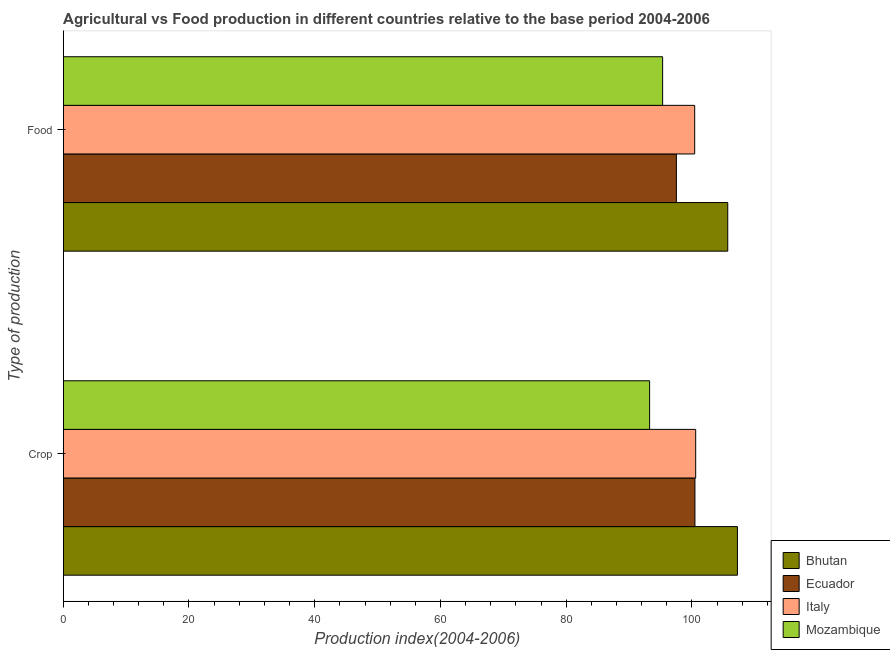How many different coloured bars are there?
Provide a short and direct response. 4. How many groups of bars are there?
Provide a short and direct response. 2. Are the number of bars per tick equal to the number of legend labels?
Provide a short and direct response. Yes. How many bars are there on the 1st tick from the top?
Give a very brief answer. 4. What is the label of the 1st group of bars from the top?
Keep it short and to the point. Food. What is the food production index in Bhutan?
Your answer should be very brief. 105.69. Across all countries, what is the maximum food production index?
Keep it short and to the point. 105.69. Across all countries, what is the minimum food production index?
Your answer should be compact. 95.33. In which country was the food production index maximum?
Ensure brevity in your answer.  Bhutan. In which country was the food production index minimum?
Your response must be concise. Mozambique. What is the total food production index in the graph?
Offer a terse response. 398.97. What is the difference between the food production index in Bhutan and that in Mozambique?
Keep it short and to the point. 10.36. What is the difference between the crop production index in Italy and the food production index in Mozambique?
Your answer should be very brief. 5.26. What is the average crop production index per country?
Provide a short and direct response. 100.39. What is the difference between the food production index and crop production index in Ecuador?
Your response must be concise. -2.95. In how many countries, is the crop production index greater than 68 ?
Keep it short and to the point. 4. What is the ratio of the food production index in Mozambique to that in Italy?
Your response must be concise. 0.95. In how many countries, is the food production index greater than the average food production index taken over all countries?
Your answer should be very brief. 2. What does the 3rd bar from the top in Crop represents?
Your answer should be very brief. Ecuador. What does the 4th bar from the bottom in Crop represents?
Keep it short and to the point. Mozambique. Are all the bars in the graph horizontal?
Your answer should be very brief. Yes. What is the difference between two consecutive major ticks on the X-axis?
Provide a succinct answer. 20. Are the values on the major ticks of X-axis written in scientific E-notation?
Offer a very short reply. No. Does the graph contain any zero values?
Keep it short and to the point. No. How are the legend labels stacked?
Provide a short and direct response. Vertical. What is the title of the graph?
Keep it short and to the point. Agricultural vs Food production in different countries relative to the base period 2004-2006. Does "Mali" appear as one of the legend labels in the graph?
Your response must be concise. No. What is the label or title of the X-axis?
Provide a succinct answer. Production index(2004-2006). What is the label or title of the Y-axis?
Your response must be concise. Type of production. What is the Production index(2004-2006) of Bhutan in Crop?
Provide a short and direct response. 107.23. What is the Production index(2004-2006) of Ecuador in Crop?
Keep it short and to the point. 100.47. What is the Production index(2004-2006) in Italy in Crop?
Make the answer very short. 100.59. What is the Production index(2004-2006) of Mozambique in Crop?
Provide a succinct answer. 93.26. What is the Production index(2004-2006) of Bhutan in Food?
Ensure brevity in your answer.  105.69. What is the Production index(2004-2006) in Ecuador in Food?
Offer a terse response. 97.52. What is the Production index(2004-2006) of Italy in Food?
Provide a succinct answer. 100.43. What is the Production index(2004-2006) in Mozambique in Food?
Offer a terse response. 95.33. Across all Type of production, what is the maximum Production index(2004-2006) in Bhutan?
Offer a terse response. 107.23. Across all Type of production, what is the maximum Production index(2004-2006) of Ecuador?
Make the answer very short. 100.47. Across all Type of production, what is the maximum Production index(2004-2006) in Italy?
Make the answer very short. 100.59. Across all Type of production, what is the maximum Production index(2004-2006) of Mozambique?
Ensure brevity in your answer.  95.33. Across all Type of production, what is the minimum Production index(2004-2006) in Bhutan?
Give a very brief answer. 105.69. Across all Type of production, what is the minimum Production index(2004-2006) of Ecuador?
Your response must be concise. 97.52. Across all Type of production, what is the minimum Production index(2004-2006) of Italy?
Offer a very short reply. 100.43. Across all Type of production, what is the minimum Production index(2004-2006) in Mozambique?
Keep it short and to the point. 93.26. What is the total Production index(2004-2006) in Bhutan in the graph?
Offer a very short reply. 212.92. What is the total Production index(2004-2006) in Ecuador in the graph?
Provide a succinct answer. 197.99. What is the total Production index(2004-2006) of Italy in the graph?
Ensure brevity in your answer.  201.02. What is the total Production index(2004-2006) of Mozambique in the graph?
Provide a short and direct response. 188.59. What is the difference between the Production index(2004-2006) of Bhutan in Crop and that in Food?
Your response must be concise. 1.54. What is the difference between the Production index(2004-2006) in Ecuador in Crop and that in Food?
Offer a terse response. 2.95. What is the difference between the Production index(2004-2006) in Italy in Crop and that in Food?
Give a very brief answer. 0.16. What is the difference between the Production index(2004-2006) of Mozambique in Crop and that in Food?
Give a very brief answer. -2.07. What is the difference between the Production index(2004-2006) in Bhutan in Crop and the Production index(2004-2006) in Ecuador in Food?
Offer a very short reply. 9.71. What is the difference between the Production index(2004-2006) in Bhutan in Crop and the Production index(2004-2006) in Mozambique in Food?
Offer a terse response. 11.9. What is the difference between the Production index(2004-2006) of Ecuador in Crop and the Production index(2004-2006) of Italy in Food?
Give a very brief answer. 0.04. What is the difference between the Production index(2004-2006) of Ecuador in Crop and the Production index(2004-2006) of Mozambique in Food?
Make the answer very short. 5.14. What is the difference between the Production index(2004-2006) of Italy in Crop and the Production index(2004-2006) of Mozambique in Food?
Provide a succinct answer. 5.26. What is the average Production index(2004-2006) in Bhutan per Type of production?
Offer a terse response. 106.46. What is the average Production index(2004-2006) of Ecuador per Type of production?
Offer a very short reply. 99. What is the average Production index(2004-2006) in Italy per Type of production?
Make the answer very short. 100.51. What is the average Production index(2004-2006) in Mozambique per Type of production?
Your answer should be compact. 94.3. What is the difference between the Production index(2004-2006) in Bhutan and Production index(2004-2006) in Ecuador in Crop?
Make the answer very short. 6.76. What is the difference between the Production index(2004-2006) in Bhutan and Production index(2004-2006) in Italy in Crop?
Offer a terse response. 6.64. What is the difference between the Production index(2004-2006) in Bhutan and Production index(2004-2006) in Mozambique in Crop?
Keep it short and to the point. 13.97. What is the difference between the Production index(2004-2006) of Ecuador and Production index(2004-2006) of Italy in Crop?
Make the answer very short. -0.12. What is the difference between the Production index(2004-2006) in Ecuador and Production index(2004-2006) in Mozambique in Crop?
Ensure brevity in your answer.  7.21. What is the difference between the Production index(2004-2006) in Italy and Production index(2004-2006) in Mozambique in Crop?
Your response must be concise. 7.33. What is the difference between the Production index(2004-2006) in Bhutan and Production index(2004-2006) in Ecuador in Food?
Your answer should be compact. 8.17. What is the difference between the Production index(2004-2006) of Bhutan and Production index(2004-2006) of Italy in Food?
Your answer should be very brief. 5.26. What is the difference between the Production index(2004-2006) of Bhutan and Production index(2004-2006) of Mozambique in Food?
Your answer should be compact. 10.36. What is the difference between the Production index(2004-2006) of Ecuador and Production index(2004-2006) of Italy in Food?
Offer a very short reply. -2.91. What is the difference between the Production index(2004-2006) in Ecuador and Production index(2004-2006) in Mozambique in Food?
Offer a terse response. 2.19. What is the ratio of the Production index(2004-2006) of Bhutan in Crop to that in Food?
Your answer should be compact. 1.01. What is the ratio of the Production index(2004-2006) of Ecuador in Crop to that in Food?
Your response must be concise. 1.03. What is the ratio of the Production index(2004-2006) in Italy in Crop to that in Food?
Offer a very short reply. 1. What is the ratio of the Production index(2004-2006) of Mozambique in Crop to that in Food?
Your answer should be very brief. 0.98. What is the difference between the highest and the second highest Production index(2004-2006) in Bhutan?
Ensure brevity in your answer.  1.54. What is the difference between the highest and the second highest Production index(2004-2006) of Ecuador?
Offer a very short reply. 2.95. What is the difference between the highest and the second highest Production index(2004-2006) in Italy?
Provide a short and direct response. 0.16. What is the difference between the highest and the second highest Production index(2004-2006) in Mozambique?
Ensure brevity in your answer.  2.07. What is the difference between the highest and the lowest Production index(2004-2006) of Bhutan?
Keep it short and to the point. 1.54. What is the difference between the highest and the lowest Production index(2004-2006) of Ecuador?
Make the answer very short. 2.95. What is the difference between the highest and the lowest Production index(2004-2006) in Italy?
Provide a short and direct response. 0.16. What is the difference between the highest and the lowest Production index(2004-2006) of Mozambique?
Make the answer very short. 2.07. 